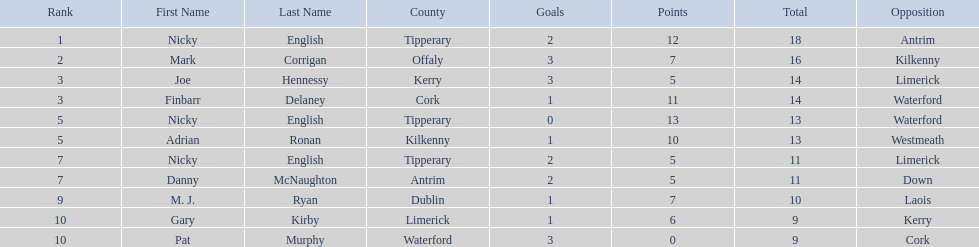Who are all the players? Nicky English, Mark Corrigan, Joe Hennessy, Finbarr Delaney, Nicky English, Adrian Ronan, Nicky English, Danny McNaughton, M. J. Ryan, Gary Kirby, Pat Murphy. How many points did they receive? 18, 16, 14, 14, 13, 13, 11, 11, 10, 9, 9. And which player received 10 points? M. J. Ryan. 